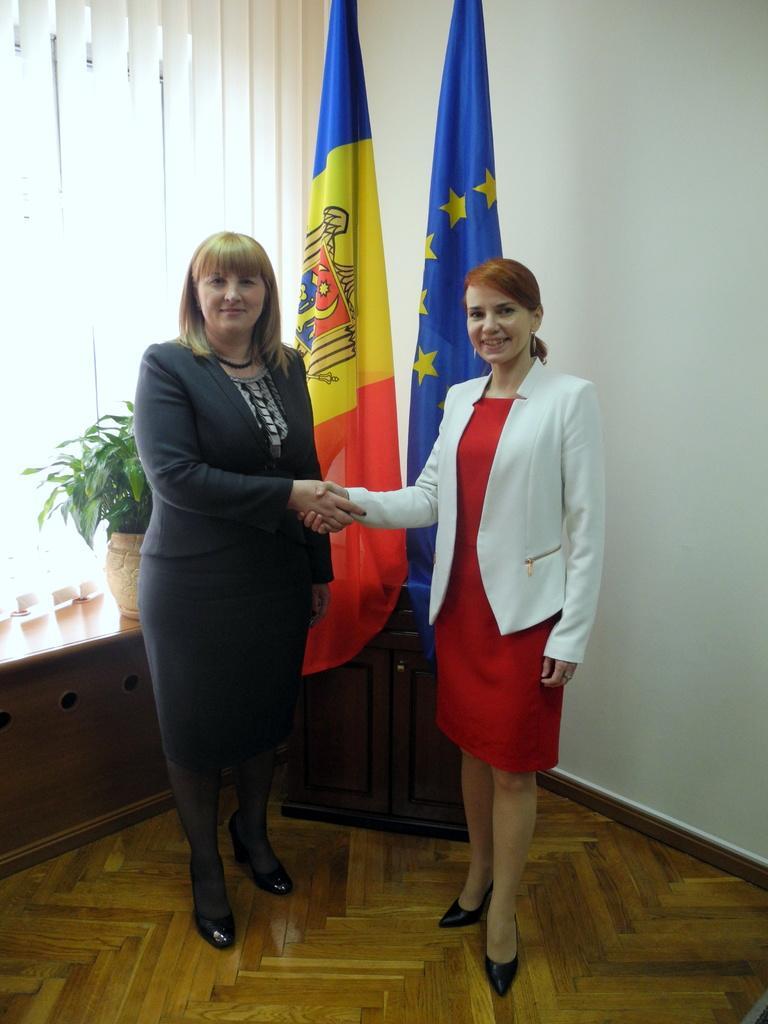Describe this image in one or two sentences. In this image, we can see two women standing on the floor, we can see two flags and there is a flower pot, we can see the white color wall. 